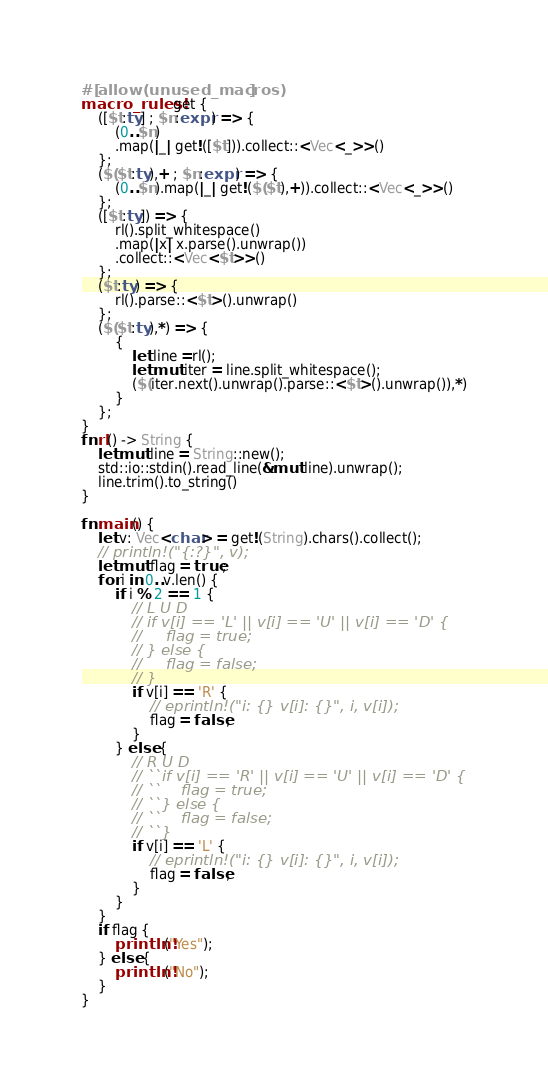Convert code to text. <code><loc_0><loc_0><loc_500><loc_500><_Rust_>#[allow(unused_macros)]
macro_rules! get {
    ([$t:ty] ; $n:expr) => {
        (0..$n)
        .map(|_| get!([$t])).collect::<Vec<_>>()
    };
    ($($t:ty),+ ; $n:expr) => {
        (0..$n).map(|_| get!($($t),+)).collect::<Vec<_>>()
    };
    ([$t:ty]) => {
        rl().split_whitespace()
        .map(|x| x.parse().unwrap())
        .collect::<Vec<$t>>()
    };
    ($t:ty) => {
        rl().parse::<$t>().unwrap()
    };
    ($($t:ty),*) => {
        {
            let line =rl();
            let mut iter = line.split_whitespace();
            ($(iter.next().unwrap().parse::<$t>().unwrap()),*)
        }
    };
}
fn rl() -> String {
    let mut line = String::new();
    std::io::stdin().read_line(&mut line).unwrap();
    line.trim().to_string()
}

fn main() {
    let v: Vec<char> = get!(String).chars().collect();
    // println!("{:?}", v);
    let mut flag = true;
    for i in 0..v.len() {
        if i % 2 == 1 {
            // L U D
            // if v[i] == 'L' || v[i] == 'U' || v[i] == 'D' {
            //     flag = true;
            // } else {
            //     flag = false;
            // }
            if v[i] == 'R' {
                // eprintln!("i: {} v[i]: {}", i, v[i]);
                flag = false;
            }
        } else {
            // R U D
            // ``if v[i] == 'R' || v[i] == 'U' || v[i] == 'D' {
            // ``    flag = true;
            // ``} else {
            // ``    flag = false;
            // ``}
            if v[i] == 'L' {
                // eprintln!("i: {} v[i]: {}", i, v[i]);
                flag = false;
            }
        }
    }
    if flag {
        println!("Yes");
    } else {
        println!("No");
    }
}
</code> 